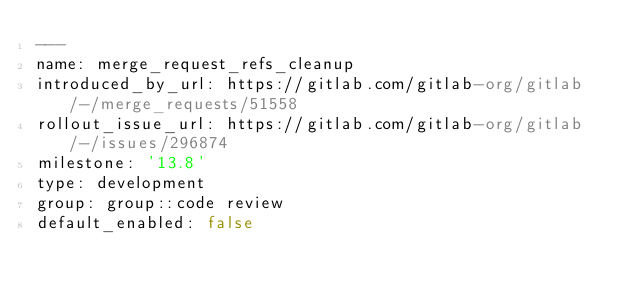Convert code to text. <code><loc_0><loc_0><loc_500><loc_500><_YAML_>---
name: merge_request_refs_cleanup
introduced_by_url: https://gitlab.com/gitlab-org/gitlab/-/merge_requests/51558
rollout_issue_url: https://gitlab.com/gitlab-org/gitlab/-/issues/296874
milestone: '13.8'
type: development
group: group::code review
default_enabled: false
</code> 